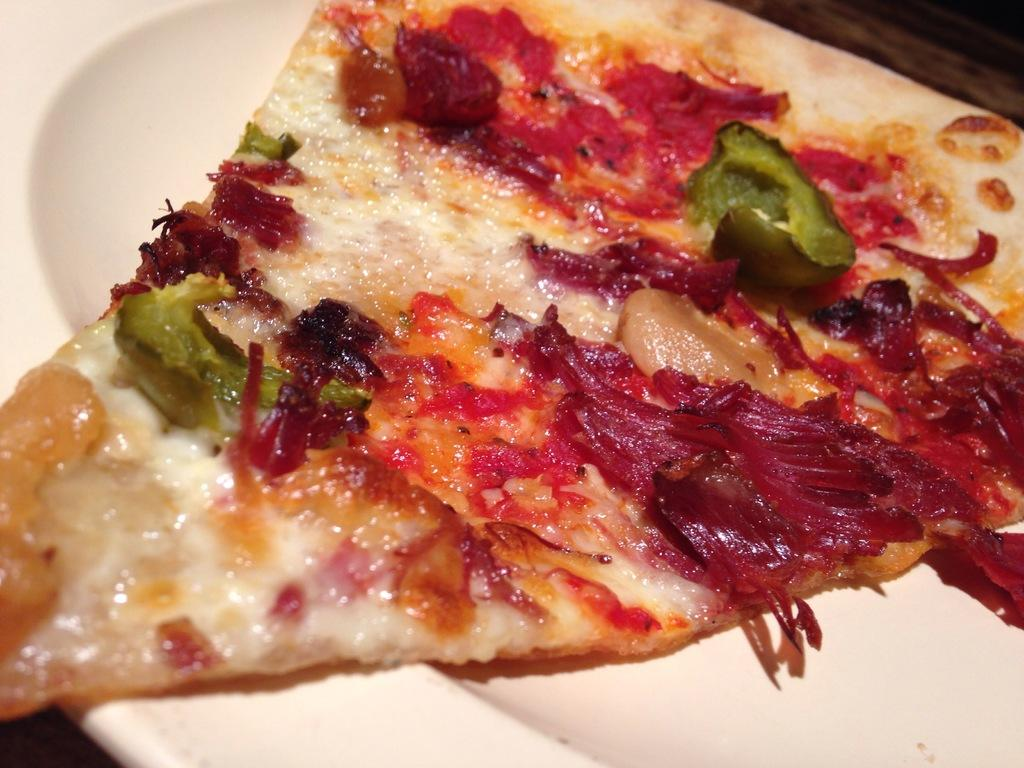What is the main subject of the image? There is a food item on a plate in the image. Can you read the letters on the food item in the image? There are no letters present on the food item in the image. How many bears are jumping over the plate in the image? There are no bears or jumping activities depicted in the image; it only features a food item on a plate. 